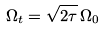Convert formula to latex. <formula><loc_0><loc_0><loc_500><loc_500>\Omega _ { t } = \sqrt { 2 \tau } \, \Omega _ { 0 }</formula> 